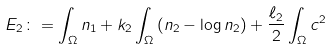<formula> <loc_0><loc_0><loc_500><loc_500>E _ { 2 } \colon = \int _ { \Omega } n _ { 1 } + k _ { 2 } \int _ { \Omega } \left ( n _ { 2 } - \log n _ { 2 } \right ) + \frac { \ell _ { 2 } } { 2 } \int _ { \Omega } c ^ { 2 }</formula> 